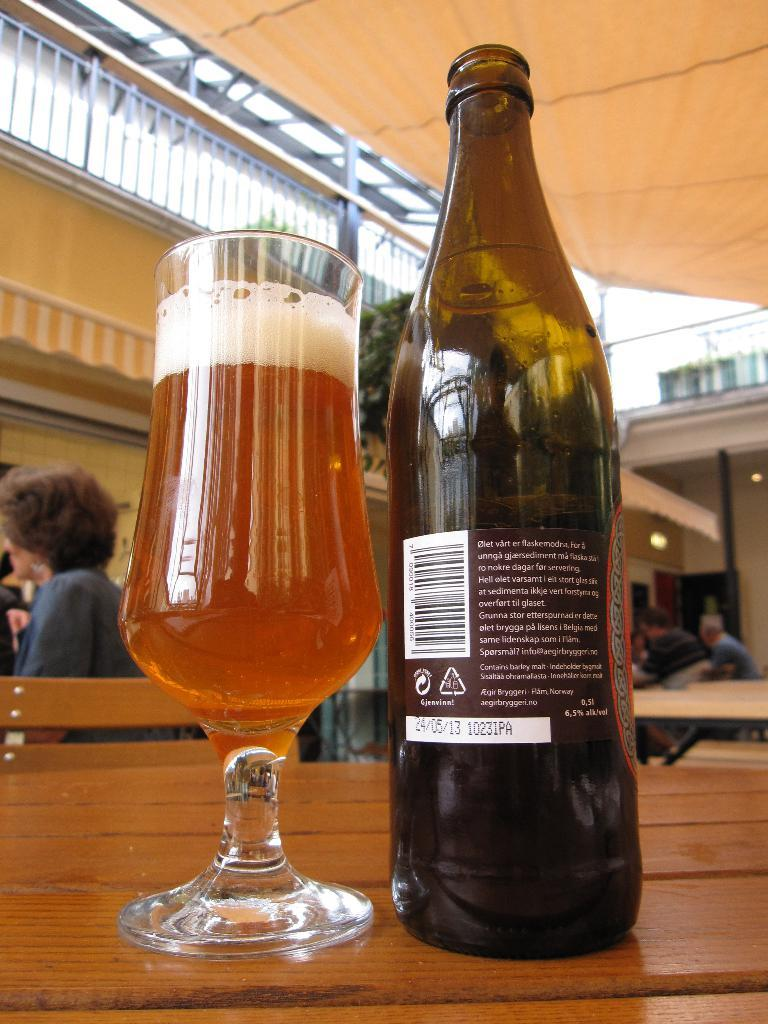Provide a one-sentence caption for the provided image. A mostly full lager glass sits on a table beside a bottle showing the reverse of a label with Danish text. 